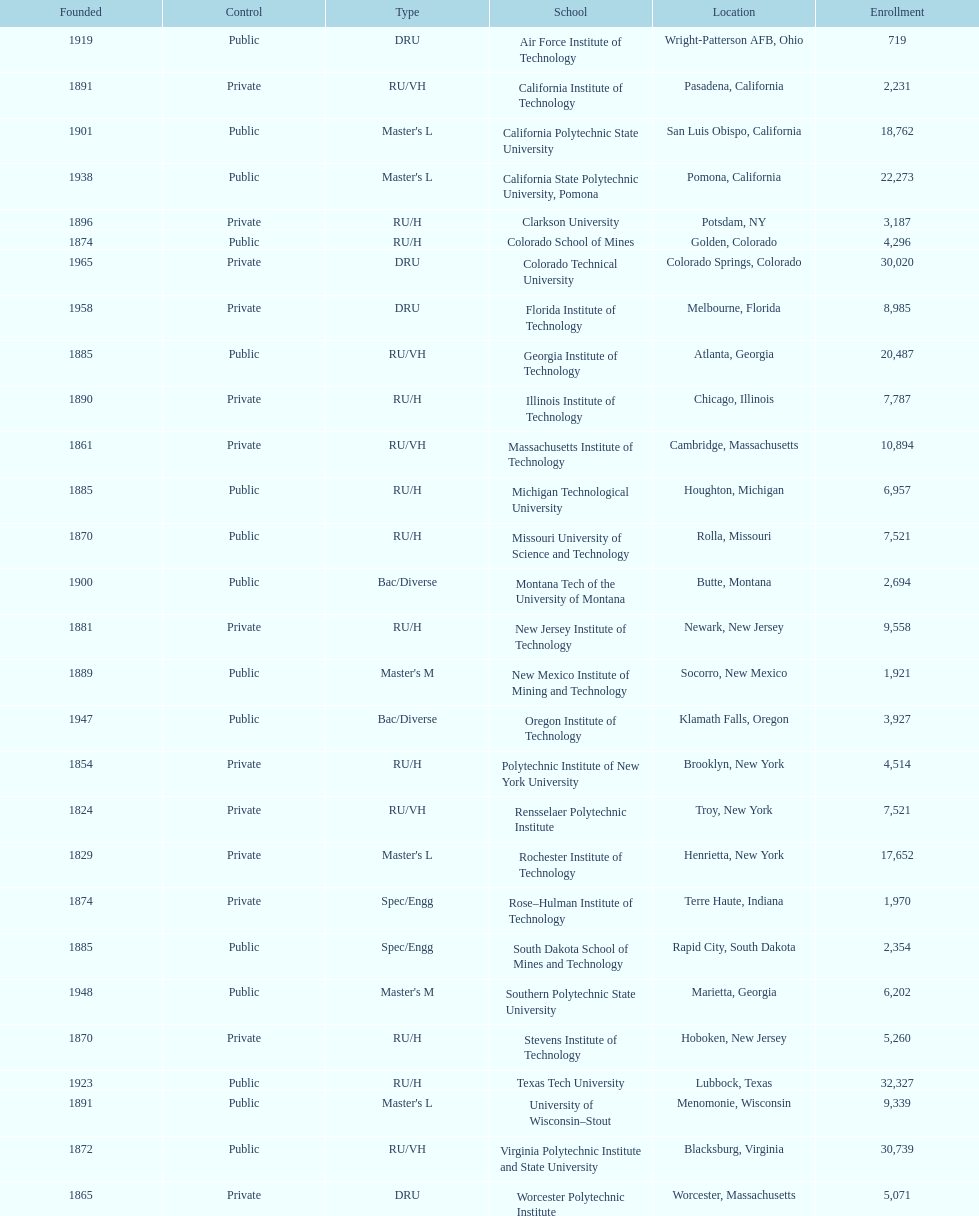What is the number of us technological schools in the state of california? 3. 